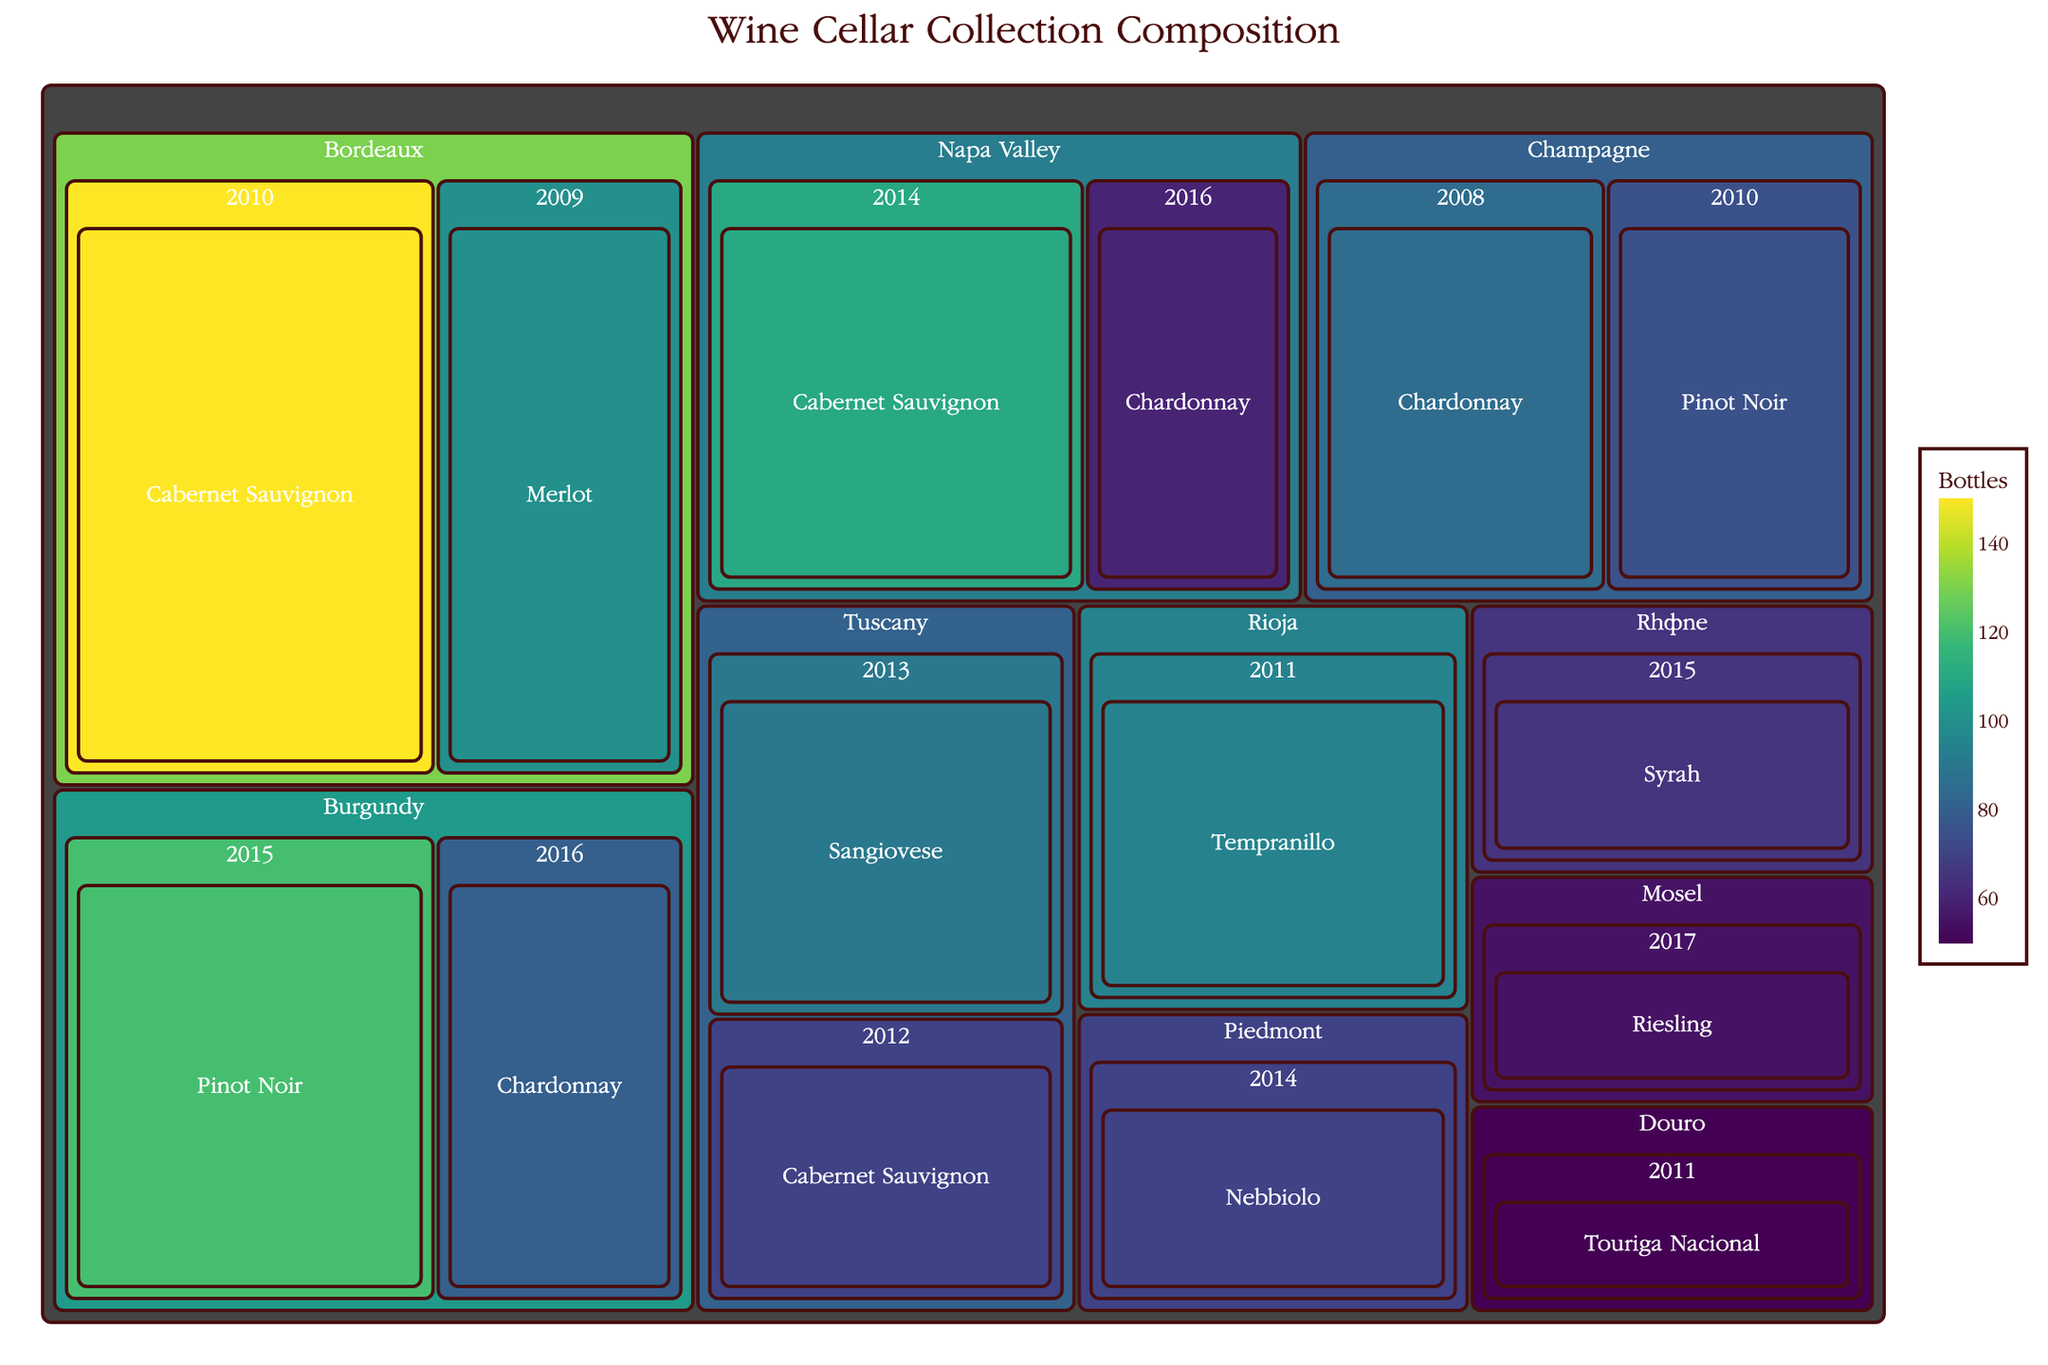what is the title of the plot? The title of the plot is typically displayed at the top of the figure. It synthesizes the main topic or the data being represented in the figure.
Answer: Wine Cellar Collection Composition Which region has the most wine bottles? By observing the size of the regions in the Treemap, the region with the largest area would indicate the highest count of wine bottles.
Answer: Bordeaux How many bottles of Cabernet Sauvignon are there in the collection? (Summation) To find the total number of Cabernet Sauvignon bottles, identify and sum up the quantities from Bordeaux 2010, Tuscany 2012, and Napa Valley 2014. Adding these gives 150 + 70 + 110.
Answer: 330 Which vintage has the smallest number of wine bottles? (Comparison) To determine the vintage with the least bottles, inspect the area size for each vintage within all regions. The smallest area corresponds to fewer bottles.
Answer: 2017 Compare the total number of Chardonnay bottles with Pinot Noir bottles. Which has more? Sum the number of Chardonnay bottles from Burgundy 2016, Napa Valley 2016, and Champagne 2008. Do the same for Pinot Noir from Burgundy 2015 and Champagne 2010. The sums are compared.
Answer: Chardonnay has more (225 Chardonnay vs. 195 Pinot Noir) What’s the average number of bottles per varietal in Bordeaux? (Average) Sum the bottles in Bordeaux (150 + 100) and divide by the number of varietals (2). The average is calculated by dividing.
Answer: 125 Which region in Italy has a higher number of wine bottles, Tuscany or Piedmont? (Comparison) Total the bottles in each Italian region: Tuscany (90 + 70) and Piedmont (70), and compare the sums.
Answer: Tuscany Identify the region and varietal that contributed the least to the collection composition. Observe the smallest section in the Treemap, which would indicate the least contribution. Region and varietal associated with that section will be the answer.
Answer: Douro, Touriga Nacional What is the total number of wine bottles in Rioja and Rhône combined? (Summation) Sum the bottles in Rioja (95) and Rhône (65) to get the combined total.
Answer: 160 Which varietal in Burgundy has more bottles? (Comparison) Compare the number of bottles between Pinot Noir (120) and Chardonnay (80) within Burgundy.
Answer: Pinot Noir 